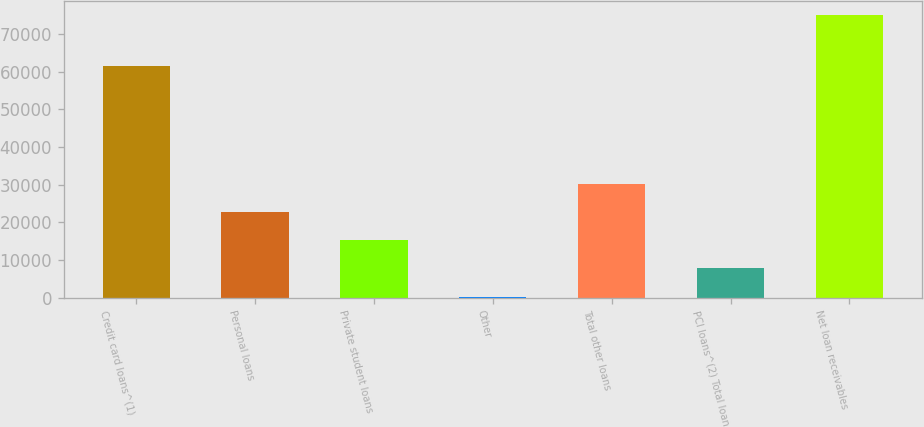Convert chart. <chart><loc_0><loc_0><loc_500><loc_500><bar_chart><fcel>Credit card loans^(1)<fcel>Personal loans<fcel>Private student loans<fcel>Other<fcel>Total other loans<fcel>PCI loans^(2) Total loan<fcel>Net loan receivables<nl><fcel>61522<fcel>22717.9<fcel>15236.6<fcel>274<fcel>30199.2<fcel>7755.3<fcel>75087<nl></chart> 